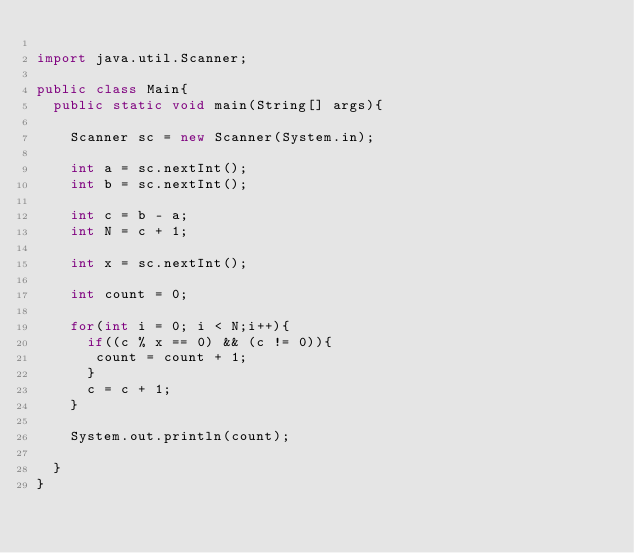Convert code to text. <code><loc_0><loc_0><loc_500><loc_500><_Java_>
import java.util.Scanner;

public class Main{
  public static void main(String[] args){

    Scanner sc = new Scanner(System.in);

    int a = sc.nextInt();
    int b = sc.nextInt();

    int c = b - a;
    int N = c + 1;

    int x = sc.nextInt();

    int count = 0;

    for(int i = 0; i < N;i++){
      if((c % x == 0) && (c != 0)){
       count = count + 1;
      }
      c = c + 1;
    }

    System.out.println(count);

  }
}</code> 